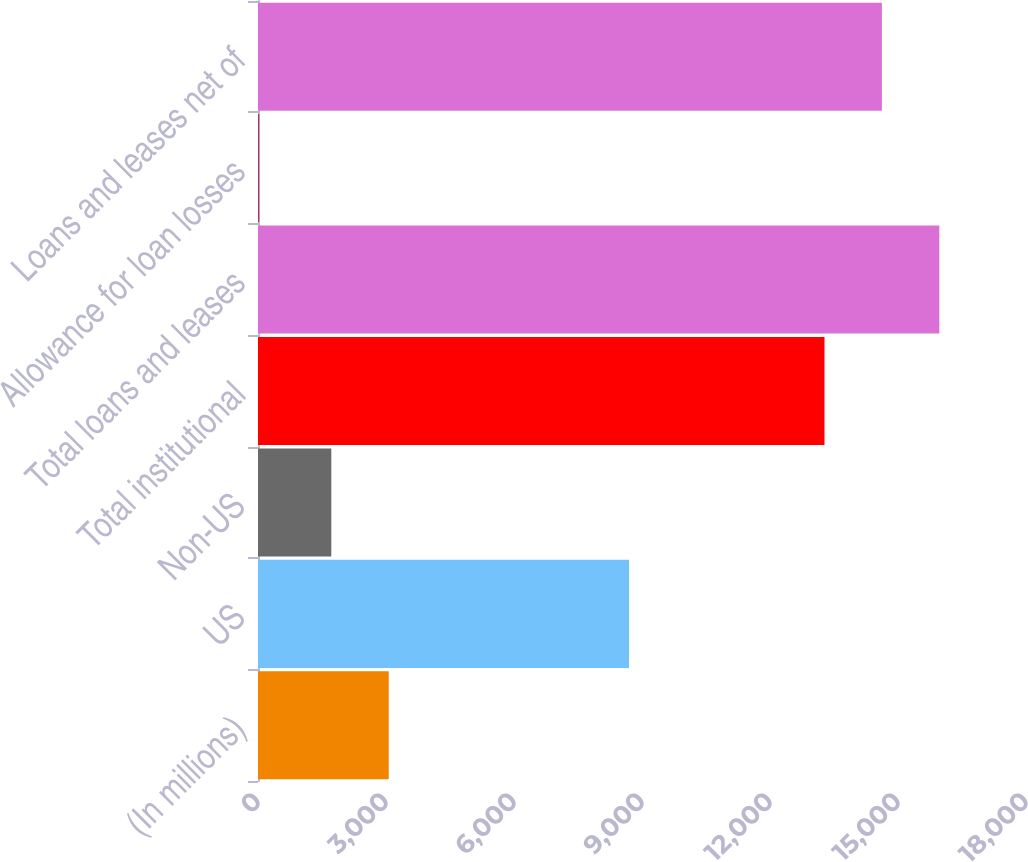Convert chart to OTSL. <chart><loc_0><loc_0><loc_500><loc_500><bar_chart><fcel>(In millions)<fcel>US<fcel>Non-US<fcel>Total institutional<fcel>Total loans and leases<fcel>Allowance for loan losses<fcel>Loans and leases net of<nl><fcel>3063.8<fcel>8695<fcel>1718<fcel>13277<fcel>15968.6<fcel>28<fcel>14622.8<nl></chart> 